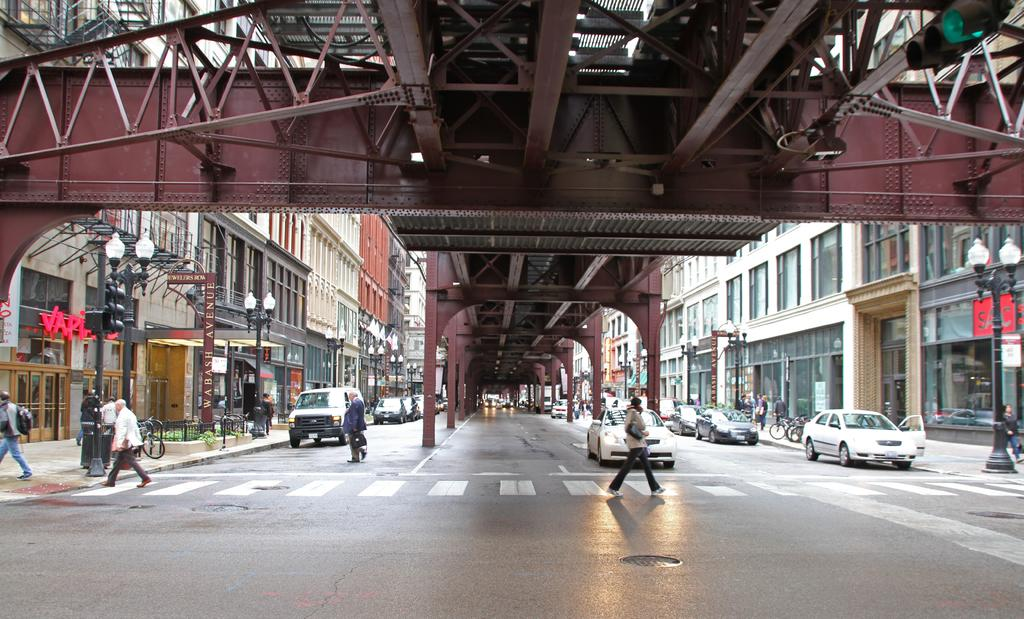Provide a one-sentence caption for the provided image. a crosswalk underneath a bridge next to a building sign that says 'SAC'. 